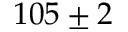Convert formula to latex. <formula><loc_0><loc_0><loc_500><loc_500>1 0 5 \pm 2</formula> 